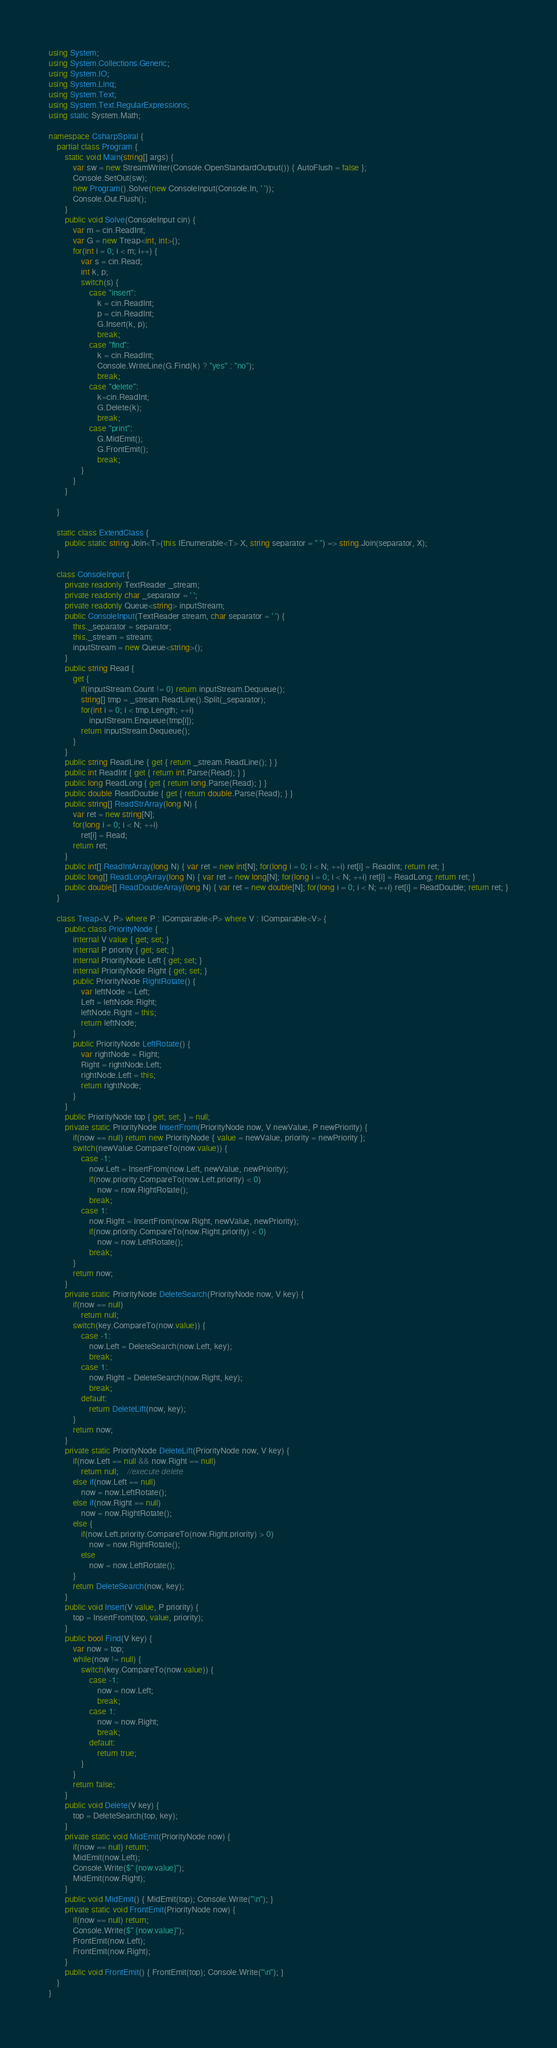Convert code to text. <code><loc_0><loc_0><loc_500><loc_500><_C#_>using System;
using System.Collections.Generic;
using System.IO;
using System.Linq;
using System.Text;
using System.Text.RegularExpressions;
using static System.Math;

namespace CsharpSpiral {
    partial class Program {
        static void Main(string[] args) {
            var sw = new StreamWriter(Console.OpenStandardOutput()) { AutoFlush = false };
            Console.SetOut(sw);
            new Program().Solve(new ConsoleInput(Console.In, ' '));
            Console.Out.Flush();
        }
        public void Solve(ConsoleInput cin) {
            var m = cin.ReadInt;
            var G = new Treap<int, int>();
            for(int i = 0; i < m; i++) {
                var s = cin.Read;
                int k, p;
                switch(s) {
                    case "insert":
                        k = cin.ReadInt;
                        p = cin.ReadInt;
                        G.Insert(k, p);
                        break;
                    case "find":
                        k = cin.ReadInt;
                        Console.WriteLine(G.Find(k) ? "yes" : "no");
                        break;
                    case "delete":
                        k=cin.ReadInt;
                        G.Delete(k);
                        break;
                    case "print":
                        G.MidEmit();
                        G.FrontEmit();
                        break;
                }
            }
        }
        
    }

    static class ExtendClass {
        public static string Join<T>(this IEnumerable<T> X, string separator = " ") => string.Join(separator, X);
    }

    class ConsoleInput {
        private readonly TextReader _stream;
        private readonly char _separator = ' ';
        private readonly Queue<string> inputStream;
        public ConsoleInput(TextReader stream, char separator = ' ') {
            this._separator = separator;
            this._stream = stream;
            inputStream = new Queue<string>();
        }
        public string Read {
            get {
                if(inputStream.Count != 0) return inputStream.Dequeue();
                string[] tmp = _stream.ReadLine().Split(_separator);
                for(int i = 0; i < tmp.Length; ++i)
                    inputStream.Enqueue(tmp[i]);
                return inputStream.Dequeue();
            }
        }
        public string ReadLine { get { return _stream.ReadLine(); } }
        public int ReadInt { get { return int.Parse(Read); } }
        public long ReadLong { get { return long.Parse(Read); } }
        public double ReadDouble { get { return double.Parse(Read); } }
        public string[] ReadStrArray(long N) {
            var ret = new string[N];
            for(long i = 0; i < N; ++i)
                ret[i] = Read;
            return ret;
        }
        public int[] ReadIntArray(long N) { var ret = new int[N]; for(long i = 0; i < N; ++i) ret[i] = ReadInt; return ret; }
        public long[] ReadLongArray(long N) { var ret = new long[N]; for(long i = 0; i < N; ++i) ret[i] = ReadLong; return ret; }
        public double[] ReadDoubleArray(long N) { var ret = new double[N]; for(long i = 0; i < N; ++i) ret[i] = ReadDouble; return ret; }
    }

	class Treap<V, P> where P : IComparable<P> where V : IComparable<V> {
		public class PriorityNode {
			internal V value { get; set; }
			internal P priority { get; set; }
			internal PriorityNode Left { get; set; }
			internal PriorityNode Right { get; set; }
			public PriorityNode RightRotate() {
				var leftNode = Left;
				Left = leftNode.Right;
				leftNode.Right = this;
				return leftNode;
			}
			public PriorityNode LeftRotate() {
				var rightNode = Right;
				Right = rightNode.Left;
				rightNode.Left = this;
				return rightNode;
			}
		}
		public PriorityNode top { get; set; } = null;
		private static PriorityNode InsertFrom(PriorityNode now, V newValue, P newPriority) {
			if(now == null) return new PriorityNode { value = newValue, priority = newPriority };
			switch(newValue.CompareTo(now.value)) {
				case -1:
					now.Left = InsertFrom(now.Left, newValue, newPriority);
					if(now.priority.CompareTo(now.Left.priority) < 0)
						now = now.RightRotate();
					break;
				case 1:
					now.Right = InsertFrom(now.Right, newValue, newPriority);
					if(now.priority.CompareTo(now.Right.priority) < 0)
						now = now.LeftRotate();
					break;
			}
			return now;
		}
		private static PriorityNode DeleteSearch(PriorityNode now, V key) {
			if(now == null)
				return null;
			switch(key.CompareTo(now.value)) {
				case -1:
					now.Left = DeleteSearch(now.Left, key);
					break;
				case 1:
					now.Right = DeleteSearch(now.Right, key);
					break;
				default:
					return DeleteLift(now, key);
			}
			return now;
		}
		private static PriorityNode DeleteLift(PriorityNode now, V key) {
			if(now.Left == null && now.Right == null)
				return null;    //execute delete
			else if(now.Left == null)
				now = now.LeftRotate();
			else if(now.Right == null)
				now = now.RightRotate();
			else {
				if(now.Left.priority.CompareTo(now.Right.priority) > 0)
					now = now.RightRotate();
				else
					now = now.LeftRotate();
			}
			return DeleteSearch(now, key);
		}
		public void Insert(V value, P priority) {
			top = InsertFrom(top, value, priority);
		}
		public bool Find(V key) {
			var now = top;
			while(now != null) {
				switch(key.CompareTo(now.value)) {
					case -1:
						now = now.Left;
						break;
					case 1:
						now = now.Right;
						break;
					default:
						return true;
				}
			}
			return false;
		}
		public void Delete(V key) {
			top = DeleteSearch(top, key);
		}
		private static void MidEmit(PriorityNode now) {
			if(now == null) return;
			MidEmit(now.Left);
			Console.Write($" {now.value}");
			MidEmit(now.Right);
		}
		public void MidEmit() { MidEmit(top); Console.Write("\n"); }
		private static void FrontEmit(PriorityNode now) {
			if(now == null) return;
			Console.Write($" {now.value}");
			FrontEmit(now.Left);
			FrontEmit(now.Right);
		}
		public void FrontEmit() { FrontEmit(top); Console.Write("\n"); }
	}
}

</code> 